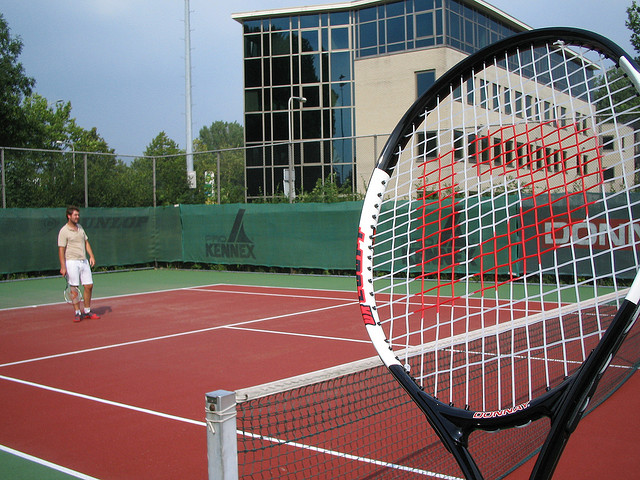Identify and read out the text in this image. DON KENNEX 